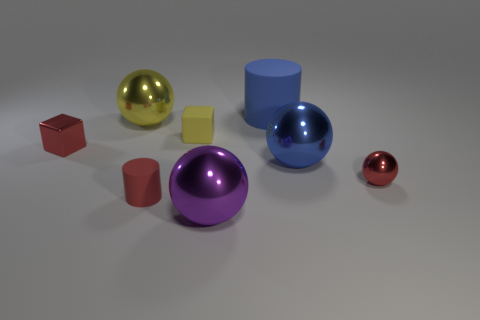There is a large metal thing in front of the small red cylinder; does it have the same color as the ball that is behind the tiny red cube?
Provide a short and direct response. No. What material is the cylinder that is to the left of the matte object to the right of the large shiny ball that is in front of the small red metal sphere?
Make the answer very short. Rubber. Is there a yellow sphere that has the same size as the purple thing?
Provide a short and direct response. Yes. There is a yellow ball that is the same size as the purple shiny ball; what is it made of?
Provide a short and direct response. Metal. There is a large object that is left of the large purple ball; what shape is it?
Provide a short and direct response. Sphere. Is the small object that is behind the red metallic block made of the same material as the small red object left of the red matte cylinder?
Your response must be concise. No. What number of tiny yellow rubber things have the same shape as the red rubber object?
Ensure brevity in your answer.  0. There is a cylinder that is the same color as the metallic block; what is it made of?
Offer a terse response. Rubber. How many objects are blue balls or big blue objects in front of the blue matte cylinder?
Give a very brief answer. 1. What material is the small red block?
Make the answer very short. Metal. 